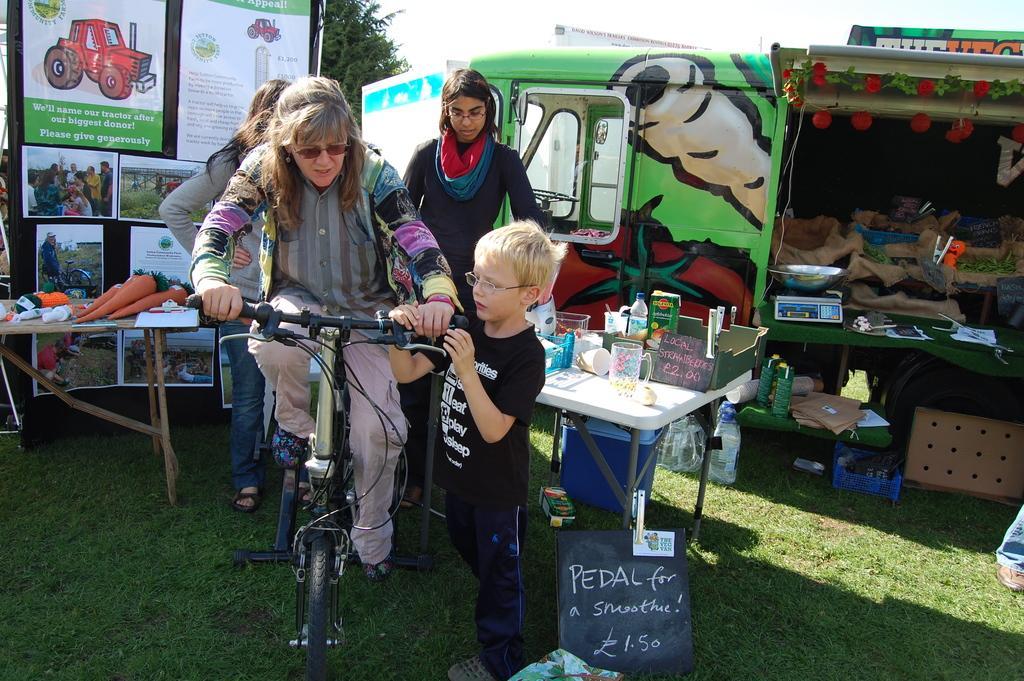Could you give a brief overview of what you see in this image? Old woman is riding a cycle beside a boy a standing by holding it he wears black color t-shirt and behind them there are banners and other things. 